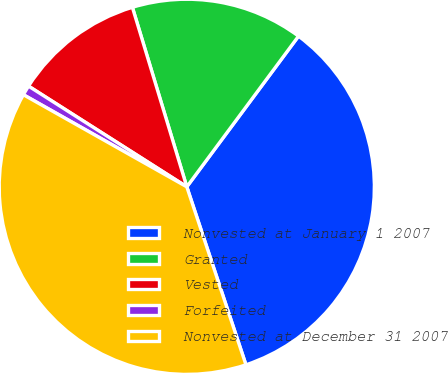Convert chart to OTSL. <chart><loc_0><loc_0><loc_500><loc_500><pie_chart><fcel>Nonvested at January 1 2007<fcel>Granted<fcel>Vested<fcel>Forfeited<fcel>Nonvested at December 31 2007<nl><fcel>34.74%<fcel>14.84%<fcel>11.3%<fcel>0.85%<fcel>38.28%<nl></chart> 